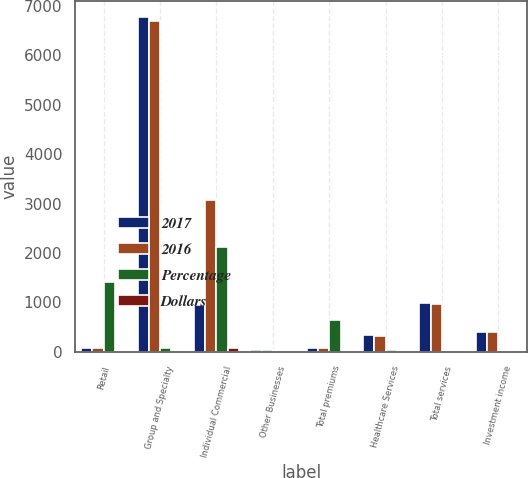Convert chart. <chart><loc_0><loc_0><loc_500><loc_500><stacked_bar_chart><ecel><fcel>Retail<fcel>Group and Specialty<fcel>Individual Commercial<fcel>Other Businesses<fcel>Total premiums<fcel>Healthcare Services<fcel>Total services<fcel>Investment income<nl><fcel>2017<fcel>72.55<fcel>6772<fcel>947<fcel>35<fcel>72.55<fcel>338<fcel>982<fcel>405<nl><fcel>2016<fcel>72.55<fcel>6696<fcel>3064<fcel>38<fcel>72.55<fcel>310<fcel>969<fcel>389<nl><fcel>Percentage<fcel>1403<fcel>76<fcel>2117<fcel>3<fcel>641<fcel>28<fcel>13<fcel>16<nl><fcel>Dollars<fcel>3.2<fcel>1.1<fcel>69.1<fcel>7.9<fcel>1.2<fcel>9<fcel>1.3<fcel>4.1<nl></chart> 